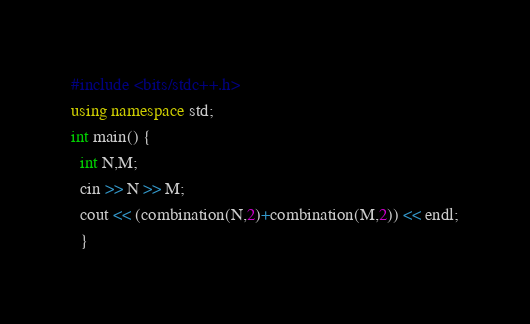<code> <loc_0><loc_0><loc_500><loc_500><_C++_>#include <bits/stdc++.h>
using namespace std;
int main() {
  int N,M;
  cin >> N >> M;
  cout << (combination(N,2)+combination(M,2)) << endl;
  }
</code> 